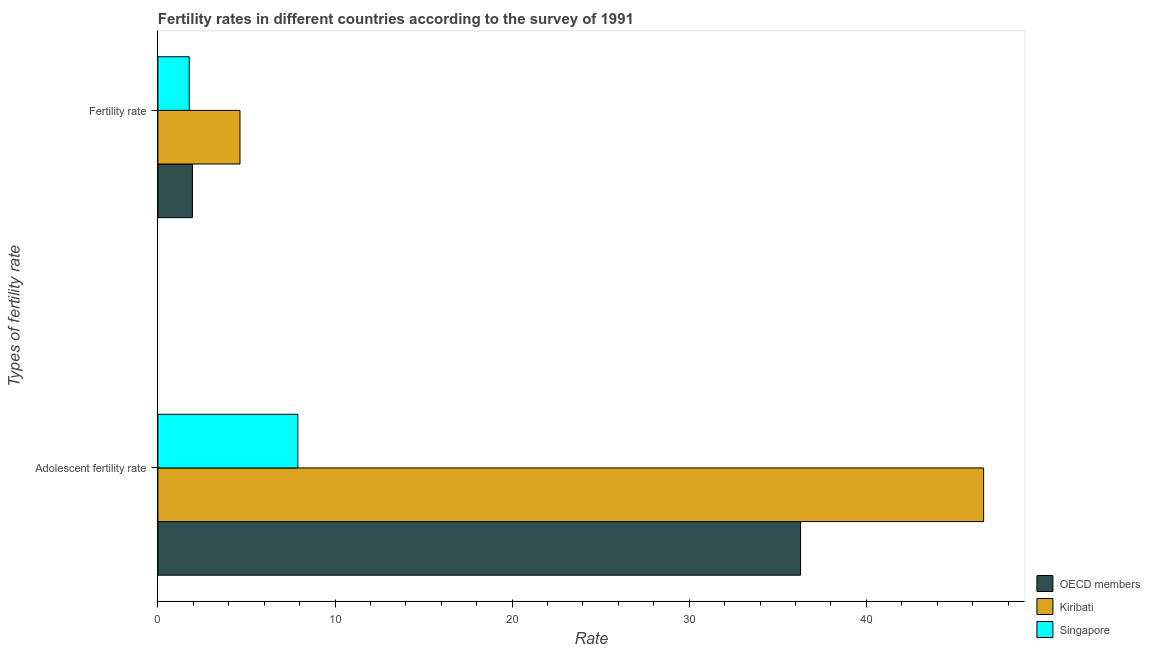How many groups of bars are there?
Offer a terse response. 2. How many bars are there on the 2nd tick from the bottom?
Offer a very short reply. 3. What is the label of the 1st group of bars from the top?
Ensure brevity in your answer.  Fertility rate. What is the fertility rate in Kiribati?
Ensure brevity in your answer.  4.63. Across all countries, what is the maximum adolescent fertility rate?
Provide a short and direct response. 46.62. Across all countries, what is the minimum adolescent fertility rate?
Provide a succinct answer. 7.9. In which country was the adolescent fertility rate maximum?
Provide a succinct answer. Kiribati. In which country was the fertility rate minimum?
Your answer should be very brief. Singapore. What is the total adolescent fertility rate in the graph?
Keep it short and to the point. 90.81. What is the difference between the fertility rate in OECD members and that in Kiribati?
Provide a short and direct response. -2.68. What is the difference between the fertility rate in Kiribati and the adolescent fertility rate in Singapore?
Your response must be concise. -3.27. What is the average adolescent fertility rate per country?
Your response must be concise. 30.27. What is the difference between the adolescent fertility rate and fertility rate in OECD members?
Make the answer very short. 34.33. In how many countries, is the adolescent fertility rate greater than 8 ?
Offer a terse response. 2. What is the ratio of the adolescent fertility rate in Kiribati to that in OECD members?
Your answer should be very brief. 1.28. In how many countries, is the fertility rate greater than the average fertility rate taken over all countries?
Your answer should be compact. 1. What does the 3rd bar from the bottom in Adolescent fertility rate represents?
Your answer should be very brief. Singapore. How many bars are there?
Ensure brevity in your answer.  6. Are all the bars in the graph horizontal?
Provide a short and direct response. Yes. How many countries are there in the graph?
Offer a terse response. 3. What is the difference between two consecutive major ticks on the X-axis?
Provide a short and direct response. 10. Are the values on the major ticks of X-axis written in scientific E-notation?
Your response must be concise. No. Where does the legend appear in the graph?
Offer a very short reply. Bottom right. How many legend labels are there?
Your answer should be compact. 3. What is the title of the graph?
Keep it short and to the point. Fertility rates in different countries according to the survey of 1991. What is the label or title of the X-axis?
Provide a succinct answer. Rate. What is the label or title of the Y-axis?
Provide a succinct answer. Types of fertility rate. What is the Rate in OECD members in Adolescent fertility rate?
Provide a short and direct response. 36.28. What is the Rate of Kiribati in Adolescent fertility rate?
Offer a very short reply. 46.62. What is the Rate in Singapore in Adolescent fertility rate?
Keep it short and to the point. 7.9. What is the Rate of OECD members in Fertility rate?
Provide a short and direct response. 1.95. What is the Rate in Kiribati in Fertility rate?
Your response must be concise. 4.63. What is the Rate in Singapore in Fertility rate?
Make the answer very short. 1.77. Across all Types of fertility rate, what is the maximum Rate of OECD members?
Give a very brief answer. 36.28. Across all Types of fertility rate, what is the maximum Rate of Kiribati?
Your response must be concise. 46.62. Across all Types of fertility rate, what is the maximum Rate of Singapore?
Keep it short and to the point. 7.9. Across all Types of fertility rate, what is the minimum Rate of OECD members?
Ensure brevity in your answer.  1.95. Across all Types of fertility rate, what is the minimum Rate of Kiribati?
Your answer should be compact. 4.63. Across all Types of fertility rate, what is the minimum Rate in Singapore?
Your answer should be very brief. 1.77. What is the total Rate of OECD members in the graph?
Give a very brief answer. 38.23. What is the total Rate in Kiribati in the graph?
Your answer should be compact. 51.26. What is the total Rate of Singapore in the graph?
Keep it short and to the point. 9.67. What is the difference between the Rate in OECD members in Adolescent fertility rate and that in Fertility rate?
Provide a succinct answer. 34.33. What is the difference between the Rate of Kiribati in Adolescent fertility rate and that in Fertility rate?
Give a very brief answer. 41.99. What is the difference between the Rate in Singapore in Adolescent fertility rate and that in Fertility rate?
Make the answer very short. 6.13. What is the difference between the Rate of OECD members in Adolescent fertility rate and the Rate of Kiribati in Fertility rate?
Offer a terse response. 31.65. What is the difference between the Rate of OECD members in Adolescent fertility rate and the Rate of Singapore in Fertility rate?
Keep it short and to the point. 34.51. What is the difference between the Rate of Kiribati in Adolescent fertility rate and the Rate of Singapore in Fertility rate?
Offer a very short reply. 44.85. What is the average Rate of OECD members per Types of fertility rate?
Offer a terse response. 19.12. What is the average Rate in Kiribati per Types of fertility rate?
Provide a short and direct response. 25.63. What is the average Rate of Singapore per Types of fertility rate?
Provide a succinct answer. 4.84. What is the difference between the Rate in OECD members and Rate in Kiribati in Adolescent fertility rate?
Your response must be concise. -10.34. What is the difference between the Rate of OECD members and Rate of Singapore in Adolescent fertility rate?
Provide a succinct answer. 28.38. What is the difference between the Rate in Kiribati and Rate in Singapore in Adolescent fertility rate?
Your response must be concise. 38.72. What is the difference between the Rate of OECD members and Rate of Kiribati in Fertility rate?
Offer a very short reply. -2.69. What is the difference between the Rate in OECD members and Rate in Singapore in Fertility rate?
Keep it short and to the point. 0.18. What is the difference between the Rate in Kiribati and Rate in Singapore in Fertility rate?
Make the answer very short. 2.87. What is the ratio of the Rate of OECD members in Adolescent fertility rate to that in Fertility rate?
Offer a very short reply. 18.61. What is the ratio of the Rate of Kiribati in Adolescent fertility rate to that in Fertility rate?
Make the answer very short. 10.06. What is the ratio of the Rate of Singapore in Adolescent fertility rate to that in Fertility rate?
Your answer should be compact. 4.46. What is the difference between the highest and the second highest Rate in OECD members?
Your answer should be compact. 34.33. What is the difference between the highest and the second highest Rate of Kiribati?
Offer a very short reply. 41.99. What is the difference between the highest and the second highest Rate in Singapore?
Offer a terse response. 6.13. What is the difference between the highest and the lowest Rate of OECD members?
Offer a very short reply. 34.33. What is the difference between the highest and the lowest Rate of Kiribati?
Offer a terse response. 41.99. What is the difference between the highest and the lowest Rate in Singapore?
Your response must be concise. 6.13. 